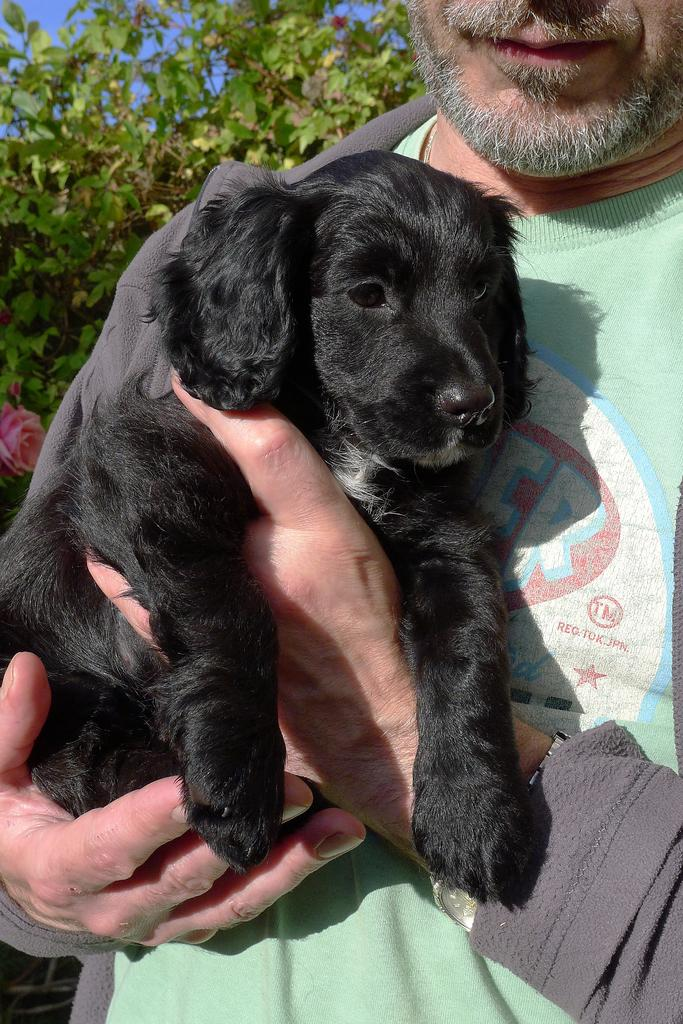What is the main subject of the image? There is a man in the image. What is the man wearing? The man is wearing a green t-shirt and a grey jacket. What is the man holding in the image? The man is holding a black dog. What can be seen in the background of the image? There is a flower, a tree, and the sky visible in the background of the image. What type of voyage is the man's aunt planning in the image? There is no mention of an aunt or a voyage in the image. 